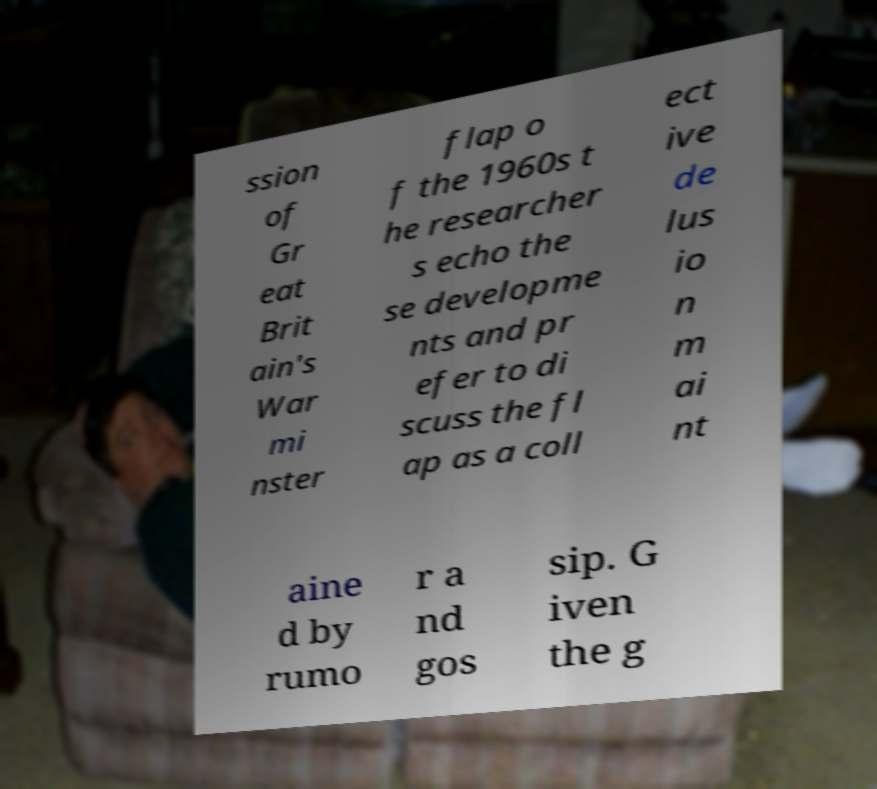There's text embedded in this image that I need extracted. Can you transcribe it verbatim? ssion of Gr eat Brit ain's War mi nster flap o f the 1960s t he researcher s echo the se developme nts and pr efer to di scuss the fl ap as a coll ect ive de lus io n m ai nt aine d by rumo r a nd gos sip. G iven the g 